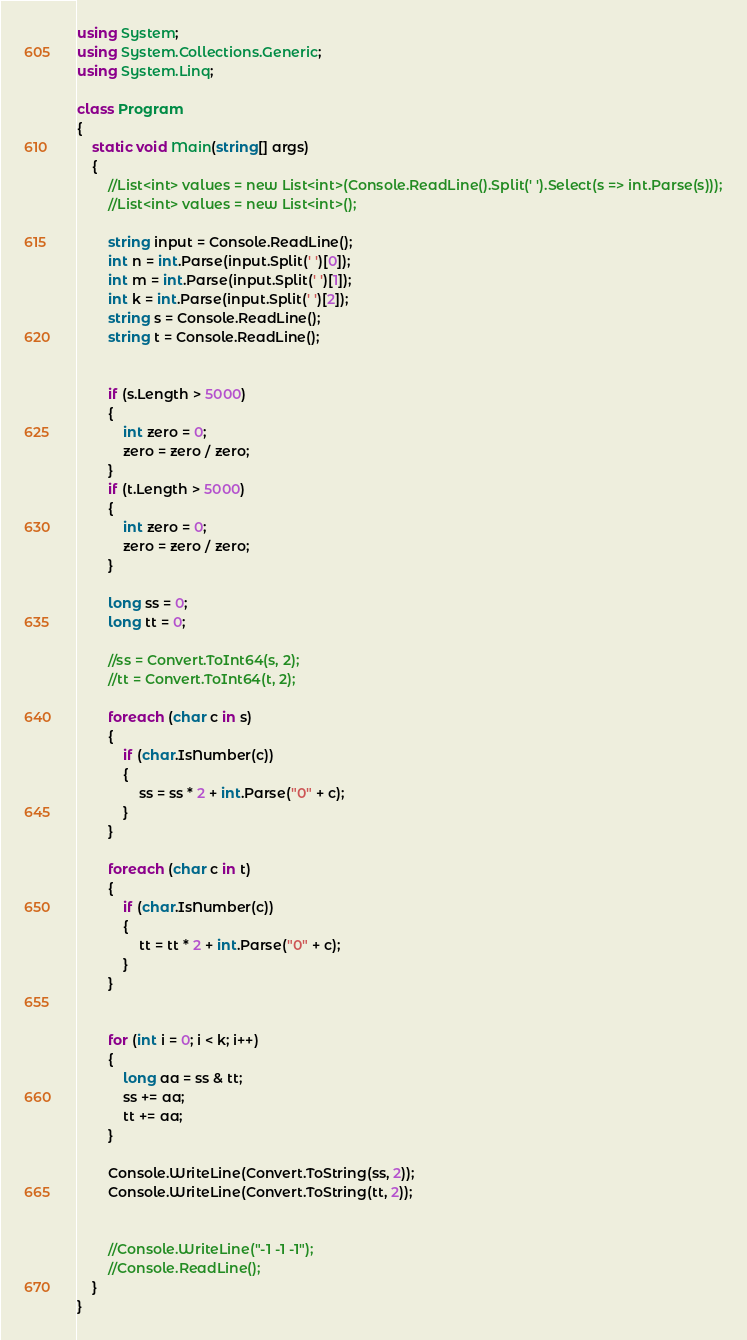Convert code to text. <code><loc_0><loc_0><loc_500><loc_500><_C#_>

using System;
using System.Collections.Generic;
using System.Linq;

class Program
{
    static void Main(string[] args)
    {   
        //List<int> values = new List<int>(Console.ReadLine().Split(' ').Select(s => int.Parse(s)));
        //List<int> values = new List<int>();

        string input = Console.ReadLine();
        int n = int.Parse(input.Split(' ')[0]);
        int m = int.Parse(input.Split(' ')[1]);
        int k = int.Parse(input.Split(' ')[2]);
        string s = Console.ReadLine();
        string t = Console.ReadLine();


        if (s.Length > 5000)
        {
            int zero = 0;
            zero = zero / zero;
        }
        if (t.Length > 5000)
        {
            int zero = 0;
            zero = zero / zero;
        }

        long ss = 0;
        long tt = 0;

        //ss = Convert.ToInt64(s, 2);
        //tt = Convert.ToInt64(t, 2);

        foreach (char c in s)
        {
            if (char.IsNumber(c))
            {
                ss = ss * 2 + int.Parse("0" + c);
            }
        }

        foreach (char c in t)
        {
            if (char.IsNumber(c))
            {
                tt = tt * 2 + int.Parse("0" + c);
            }
        }


        for (int i = 0; i < k; i++)
        {
            long aa = ss & tt;
            ss += aa;
            tt += aa;
        }

        Console.WriteLine(Convert.ToString(ss, 2));
        Console.WriteLine(Convert.ToString(tt, 2));


        //Console.WriteLine("-1 -1 -1");
        //Console.ReadLine();
    }
}</code> 